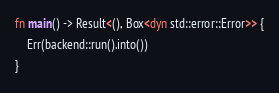<code> <loc_0><loc_0><loc_500><loc_500><_Rust_>fn main() -> Result<(), Box<dyn std::error::Error>> {
    Err(backend::run().into())
}
</code> 